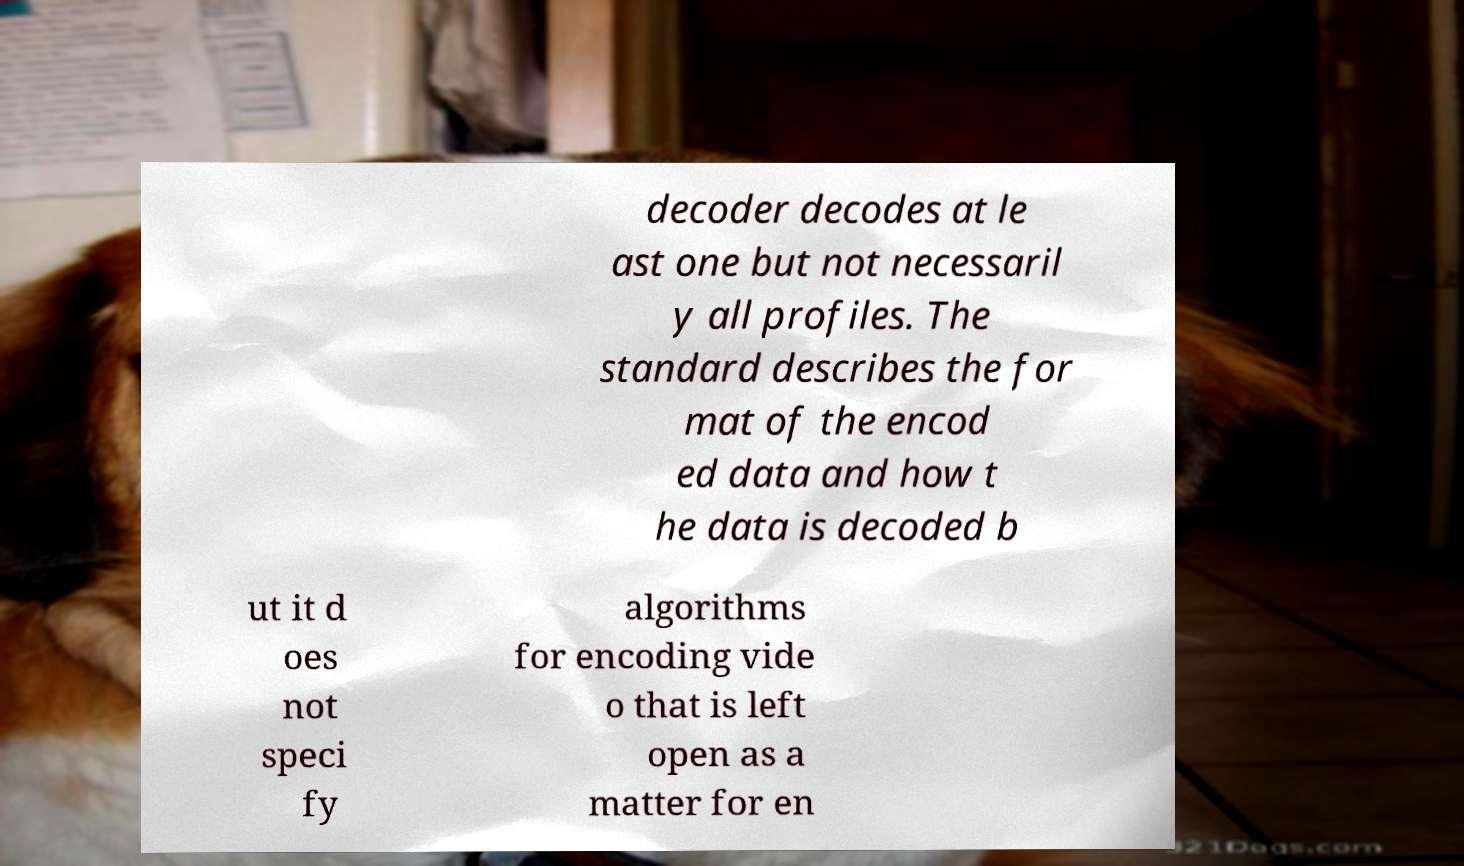There's text embedded in this image that I need extracted. Can you transcribe it verbatim? decoder decodes at le ast one but not necessaril y all profiles. The standard describes the for mat of the encod ed data and how t he data is decoded b ut it d oes not speci fy algorithms for encoding vide o that is left open as a matter for en 